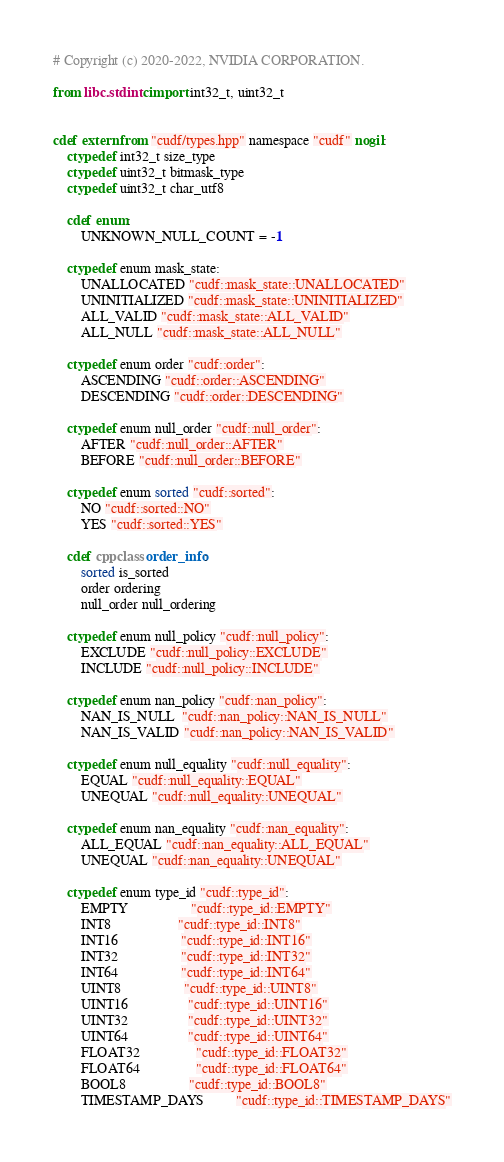<code> <loc_0><loc_0><loc_500><loc_500><_Cython_># Copyright (c) 2020-2022, NVIDIA CORPORATION.

from libc.stdint cimport int32_t, uint32_t


cdef extern from "cudf/types.hpp" namespace "cudf" nogil:
    ctypedef int32_t size_type
    ctypedef uint32_t bitmask_type
    ctypedef uint32_t char_utf8

    cdef enum:
        UNKNOWN_NULL_COUNT = -1

    ctypedef enum mask_state:
        UNALLOCATED "cudf::mask_state::UNALLOCATED"
        UNINITIALIZED "cudf::mask_state::UNINITIALIZED"
        ALL_VALID "cudf::mask_state::ALL_VALID"
        ALL_NULL "cudf::mask_state::ALL_NULL"

    ctypedef enum order "cudf::order":
        ASCENDING "cudf::order::ASCENDING"
        DESCENDING "cudf::order::DESCENDING"

    ctypedef enum null_order "cudf::null_order":
        AFTER "cudf::null_order::AFTER"
        BEFORE "cudf::null_order::BEFORE"

    ctypedef enum sorted "cudf::sorted":
        NO "cudf::sorted::NO"
        YES "cudf::sorted::YES"

    cdef cppclass order_info:
        sorted is_sorted
        order ordering
        null_order null_ordering

    ctypedef enum null_policy "cudf::null_policy":
        EXCLUDE "cudf::null_policy::EXCLUDE"
        INCLUDE "cudf::null_policy::INCLUDE"

    ctypedef enum nan_policy "cudf::nan_policy":
        NAN_IS_NULL  "cudf::nan_policy::NAN_IS_NULL"
        NAN_IS_VALID "cudf::nan_policy::NAN_IS_VALID"

    ctypedef enum null_equality "cudf::null_equality":
        EQUAL "cudf::null_equality::EQUAL"
        UNEQUAL "cudf::null_equality::UNEQUAL"

    ctypedef enum nan_equality "cudf::nan_equality":
        ALL_EQUAL "cudf::nan_equality::ALL_EQUAL"
        UNEQUAL "cudf::nan_equality::UNEQUAL"

    ctypedef enum type_id "cudf::type_id":
        EMPTY                  "cudf::type_id::EMPTY"
        INT8                   "cudf::type_id::INT8"
        INT16                  "cudf::type_id::INT16"
        INT32                  "cudf::type_id::INT32"
        INT64                  "cudf::type_id::INT64"
        UINT8                  "cudf::type_id::UINT8"
        UINT16                 "cudf::type_id::UINT16"
        UINT32                 "cudf::type_id::UINT32"
        UINT64                 "cudf::type_id::UINT64"
        FLOAT32                "cudf::type_id::FLOAT32"
        FLOAT64                "cudf::type_id::FLOAT64"
        BOOL8                  "cudf::type_id::BOOL8"
        TIMESTAMP_DAYS         "cudf::type_id::TIMESTAMP_DAYS"</code> 